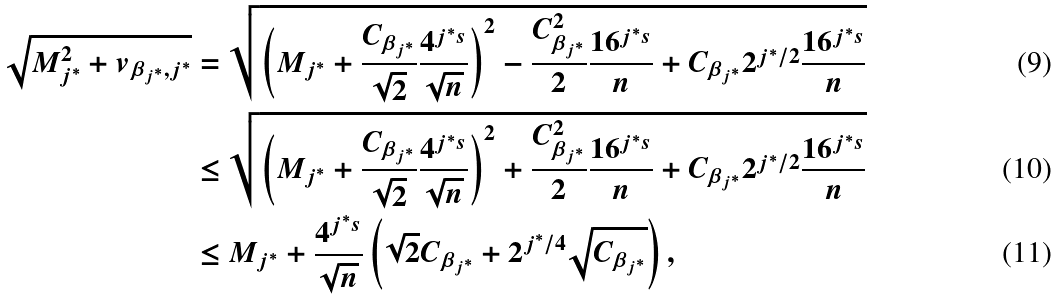<formula> <loc_0><loc_0><loc_500><loc_500>\sqrt { M _ { j ^ { \ast } } ^ { 2 } + v _ { \beta _ { j ^ { \ast } } , j ^ { \ast } } } & = \sqrt { \left ( M _ { j ^ { \ast } } + \frac { C _ { \beta _ { j ^ { \ast } } } } { \sqrt { 2 } } \frac { 4 ^ { j ^ { \ast } s } } { \sqrt { n } } \right ) ^ { 2 } - \frac { C _ { \beta _ { j ^ { \ast } } } ^ { 2 } } { 2 } \frac { 1 6 ^ { j ^ { \ast } s } } { n } + C _ { \beta _ { j ^ { \ast } } } 2 ^ { j ^ { \ast } / 2 } \frac { 1 6 ^ { j ^ { \ast } s } } { n } } \\ & \leq \sqrt { \left ( M _ { j ^ { \ast } } + \frac { C _ { \beta _ { j ^ { \ast } } } } { \sqrt { 2 } } \frac { 4 ^ { j ^ { \ast } s } } { \sqrt { n } } \right ) ^ { 2 } + \frac { C _ { \beta _ { j ^ { \ast } } } ^ { 2 } } { 2 } \frac { 1 6 ^ { j ^ { \ast } s } } { n } + C _ { \beta _ { j ^ { \ast } } } 2 ^ { j ^ { \ast } / 2 } \frac { 1 6 ^ { j ^ { \ast } s } } { n } } \\ & \leq M _ { j ^ { \ast } } + \frac { 4 ^ { j ^ { \ast } s } } { \sqrt { n } } \left ( \sqrt { 2 } C _ { \beta _ { j ^ { \ast } } } + 2 ^ { j ^ { \ast } / 4 } \sqrt { C _ { \beta _ { j ^ { \ast } } } } \right ) ,</formula> 